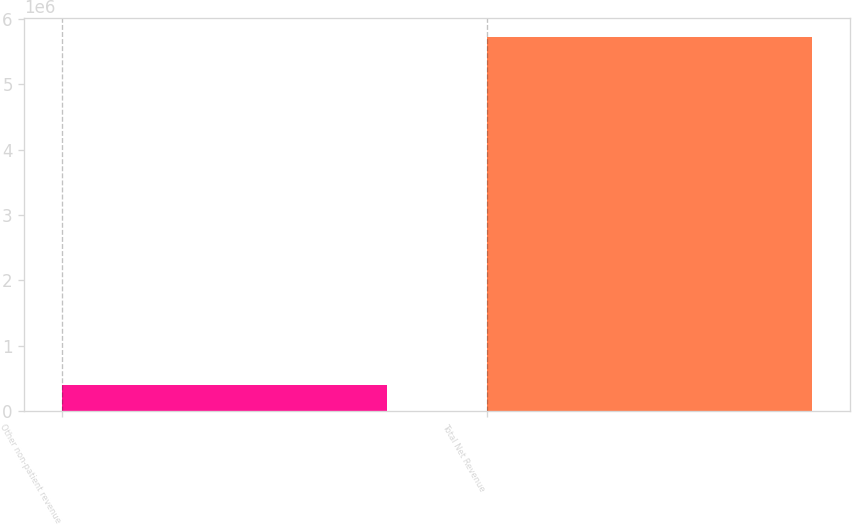Convert chart. <chart><loc_0><loc_0><loc_500><loc_500><bar_chart><fcel>Other non-patient revenue<fcel>Total Net Revenue<nl><fcel>390271<fcel>5.7199e+06<nl></chart> 